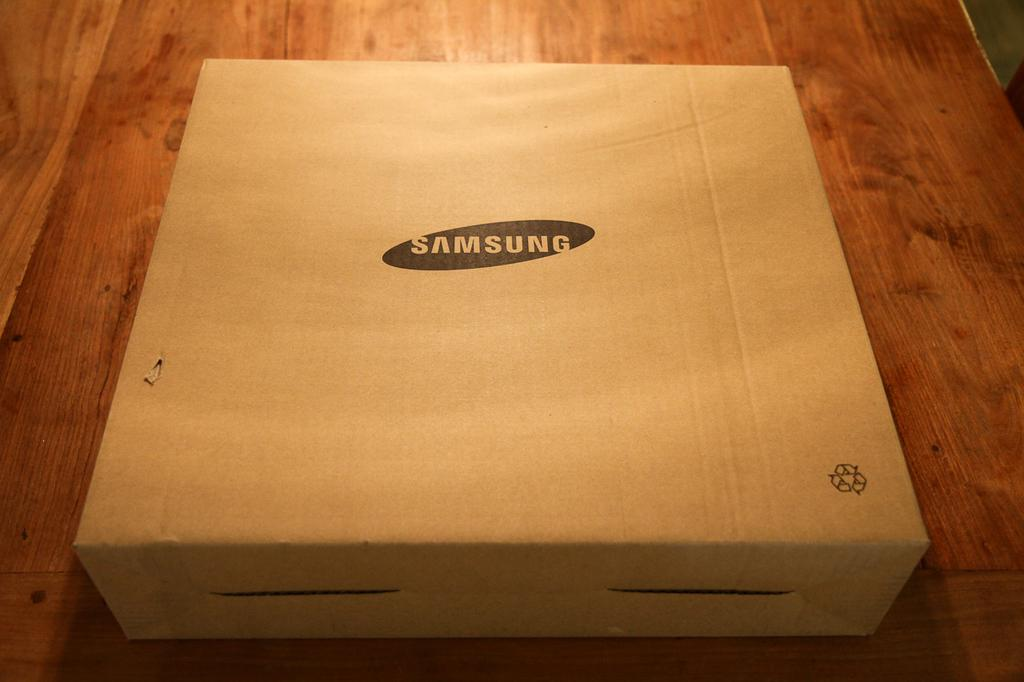<image>
Describe the image concisely. Light brown box with the words Samsung laying on the wood floor. 